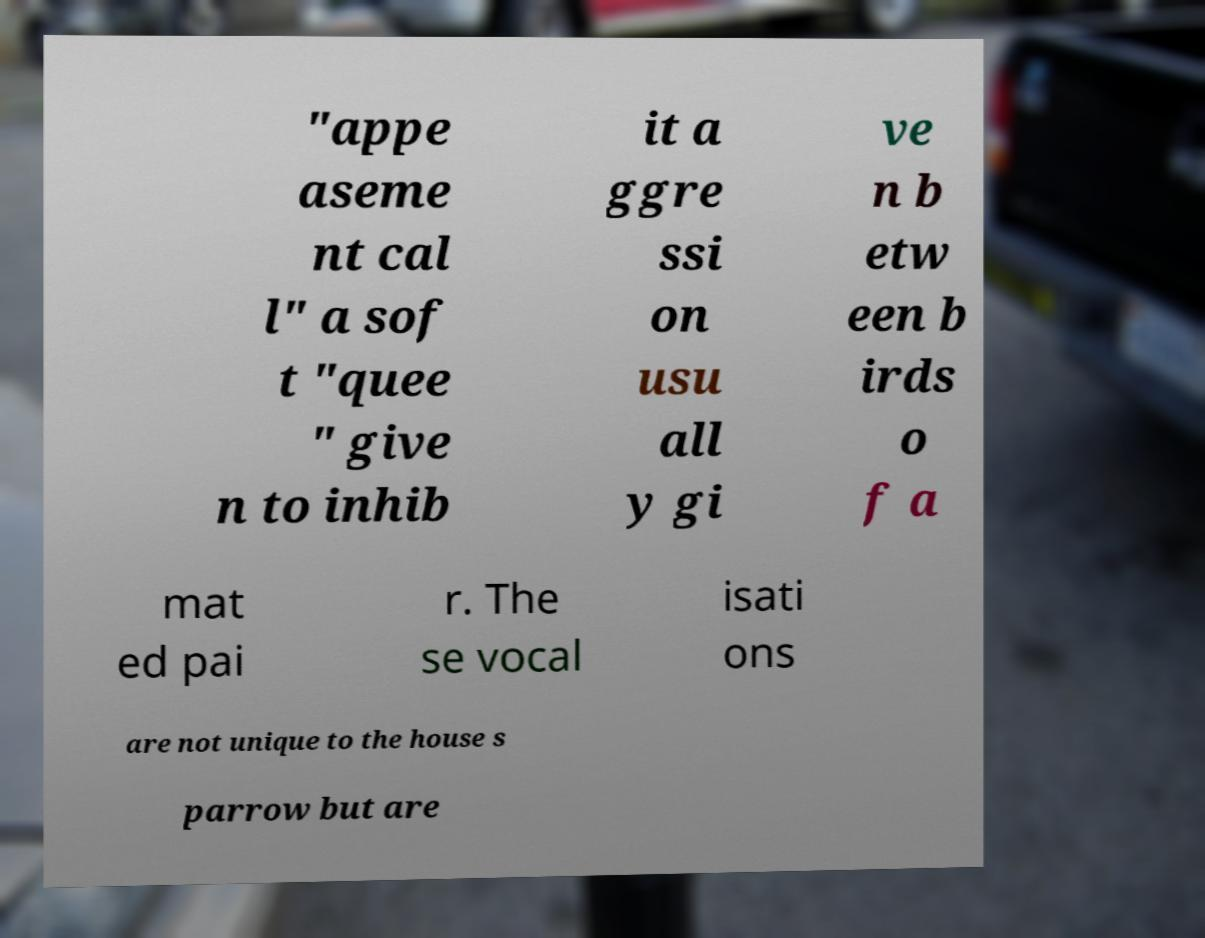There's text embedded in this image that I need extracted. Can you transcribe it verbatim? "appe aseme nt cal l" a sof t "quee " give n to inhib it a ggre ssi on usu all y gi ve n b etw een b irds o f a mat ed pai r. The se vocal isati ons are not unique to the house s parrow but are 